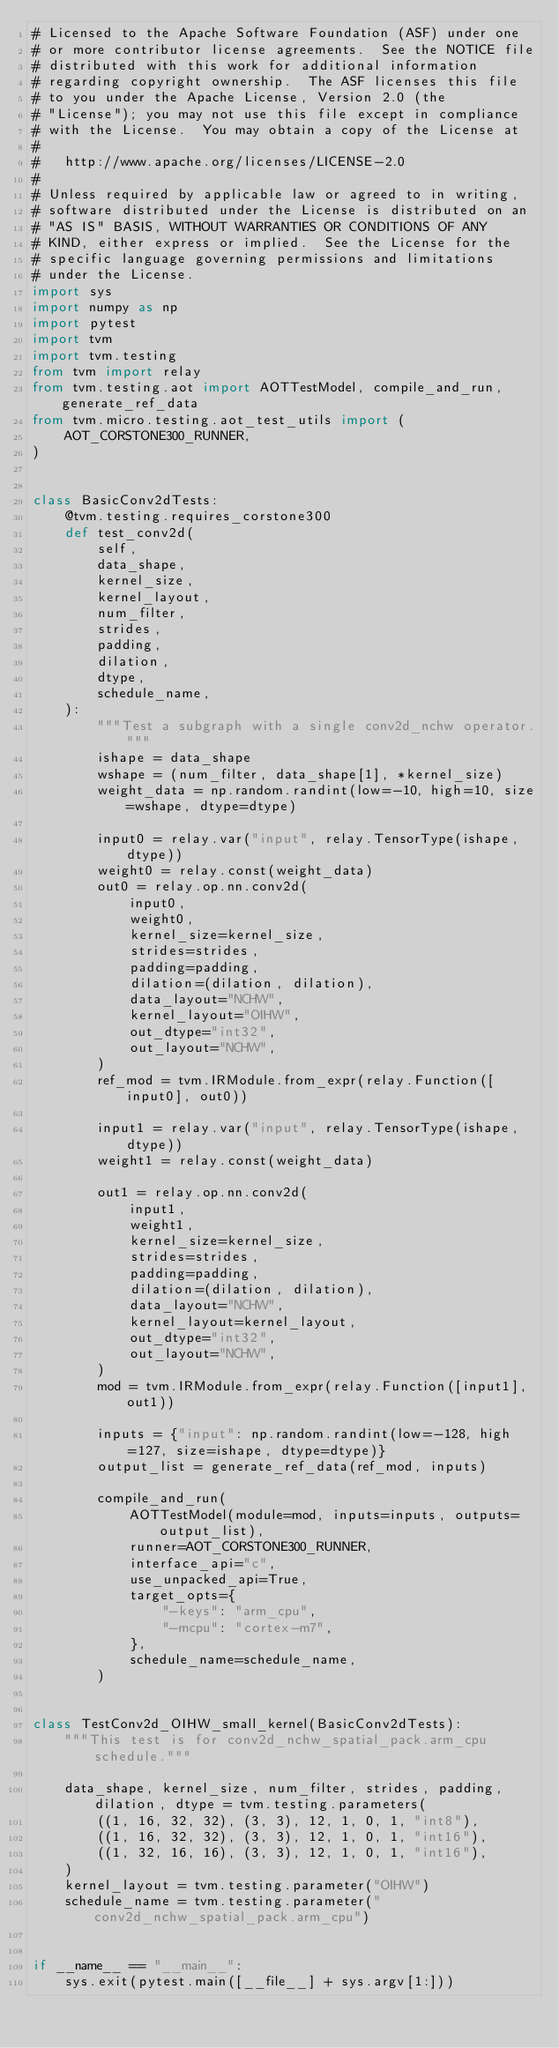<code> <loc_0><loc_0><loc_500><loc_500><_Python_># Licensed to the Apache Software Foundation (ASF) under one
# or more contributor license agreements.  See the NOTICE file
# distributed with this work for additional information
# regarding copyright ownership.  The ASF licenses this file
# to you under the Apache License, Version 2.0 (the
# "License"); you may not use this file except in compliance
# with the License.  You may obtain a copy of the License at
#
#   http://www.apache.org/licenses/LICENSE-2.0
#
# Unless required by applicable law or agreed to in writing,
# software distributed under the License is distributed on an
# "AS IS" BASIS, WITHOUT WARRANTIES OR CONDITIONS OF ANY
# KIND, either express or implied.  See the License for the
# specific language governing permissions and limitations
# under the License.
import sys
import numpy as np
import pytest
import tvm
import tvm.testing
from tvm import relay
from tvm.testing.aot import AOTTestModel, compile_and_run, generate_ref_data
from tvm.micro.testing.aot_test_utils import (
    AOT_CORSTONE300_RUNNER,
)


class BasicConv2dTests:
    @tvm.testing.requires_corstone300
    def test_conv2d(
        self,
        data_shape,
        kernel_size,
        kernel_layout,
        num_filter,
        strides,
        padding,
        dilation,
        dtype,
        schedule_name,
    ):
        """Test a subgraph with a single conv2d_nchw operator."""
        ishape = data_shape
        wshape = (num_filter, data_shape[1], *kernel_size)
        weight_data = np.random.randint(low=-10, high=10, size=wshape, dtype=dtype)

        input0 = relay.var("input", relay.TensorType(ishape, dtype))
        weight0 = relay.const(weight_data)
        out0 = relay.op.nn.conv2d(
            input0,
            weight0,
            kernel_size=kernel_size,
            strides=strides,
            padding=padding,
            dilation=(dilation, dilation),
            data_layout="NCHW",
            kernel_layout="OIHW",
            out_dtype="int32",
            out_layout="NCHW",
        )
        ref_mod = tvm.IRModule.from_expr(relay.Function([input0], out0))

        input1 = relay.var("input", relay.TensorType(ishape, dtype))
        weight1 = relay.const(weight_data)

        out1 = relay.op.nn.conv2d(
            input1,
            weight1,
            kernel_size=kernel_size,
            strides=strides,
            padding=padding,
            dilation=(dilation, dilation),
            data_layout="NCHW",
            kernel_layout=kernel_layout,
            out_dtype="int32",
            out_layout="NCHW",
        )
        mod = tvm.IRModule.from_expr(relay.Function([input1], out1))

        inputs = {"input": np.random.randint(low=-128, high=127, size=ishape, dtype=dtype)}
        output_list = generate_ref_data(ref_mod, inputs)

        compile_and_run(
            AOTTestModel(module=mod, inputs=inputs, outputs=output_list),
            runner=AOT_CORSTONE300_RUNNER,
            interface_api="c",
            use_unpacked_api=True,
            target_opts={
                "-keys": "arm_cpu",
                "-mcpu": "cortex-m7",
            },
            schedule_name=schedule_name,
        )


class TestConv2d_OIHW_small_kernel(BasicConv2dTests):
    """This test is for conv2d_nchw_spatial_pack.arm_cpu schedule."""

    data_shape, kernel_size, num_filter, strides, padding, dilation, dtype = tvm.testing.parameters(
        ((1, 16, 32, 32), (3, 3), 12, 1, 0, 1, "int8"),
        ((1, 16, 32, 32), (3, 3), 12, 1, 0, 1, "int16"),
        ((1, 32, 16, 16), (3, 3), 12, 1, 0, 1, "int16"),
    )
    kernel_layout = tvm.testing.parameter("OIHW")
    schedule_name = tvm.testing.parameter("conv2d_nchw_spatial_pack.arm_cpu")


if __name__ == "__main__":
    sys.exit(pytest.main([__file__] + sys.argv[1:]))
</code> 